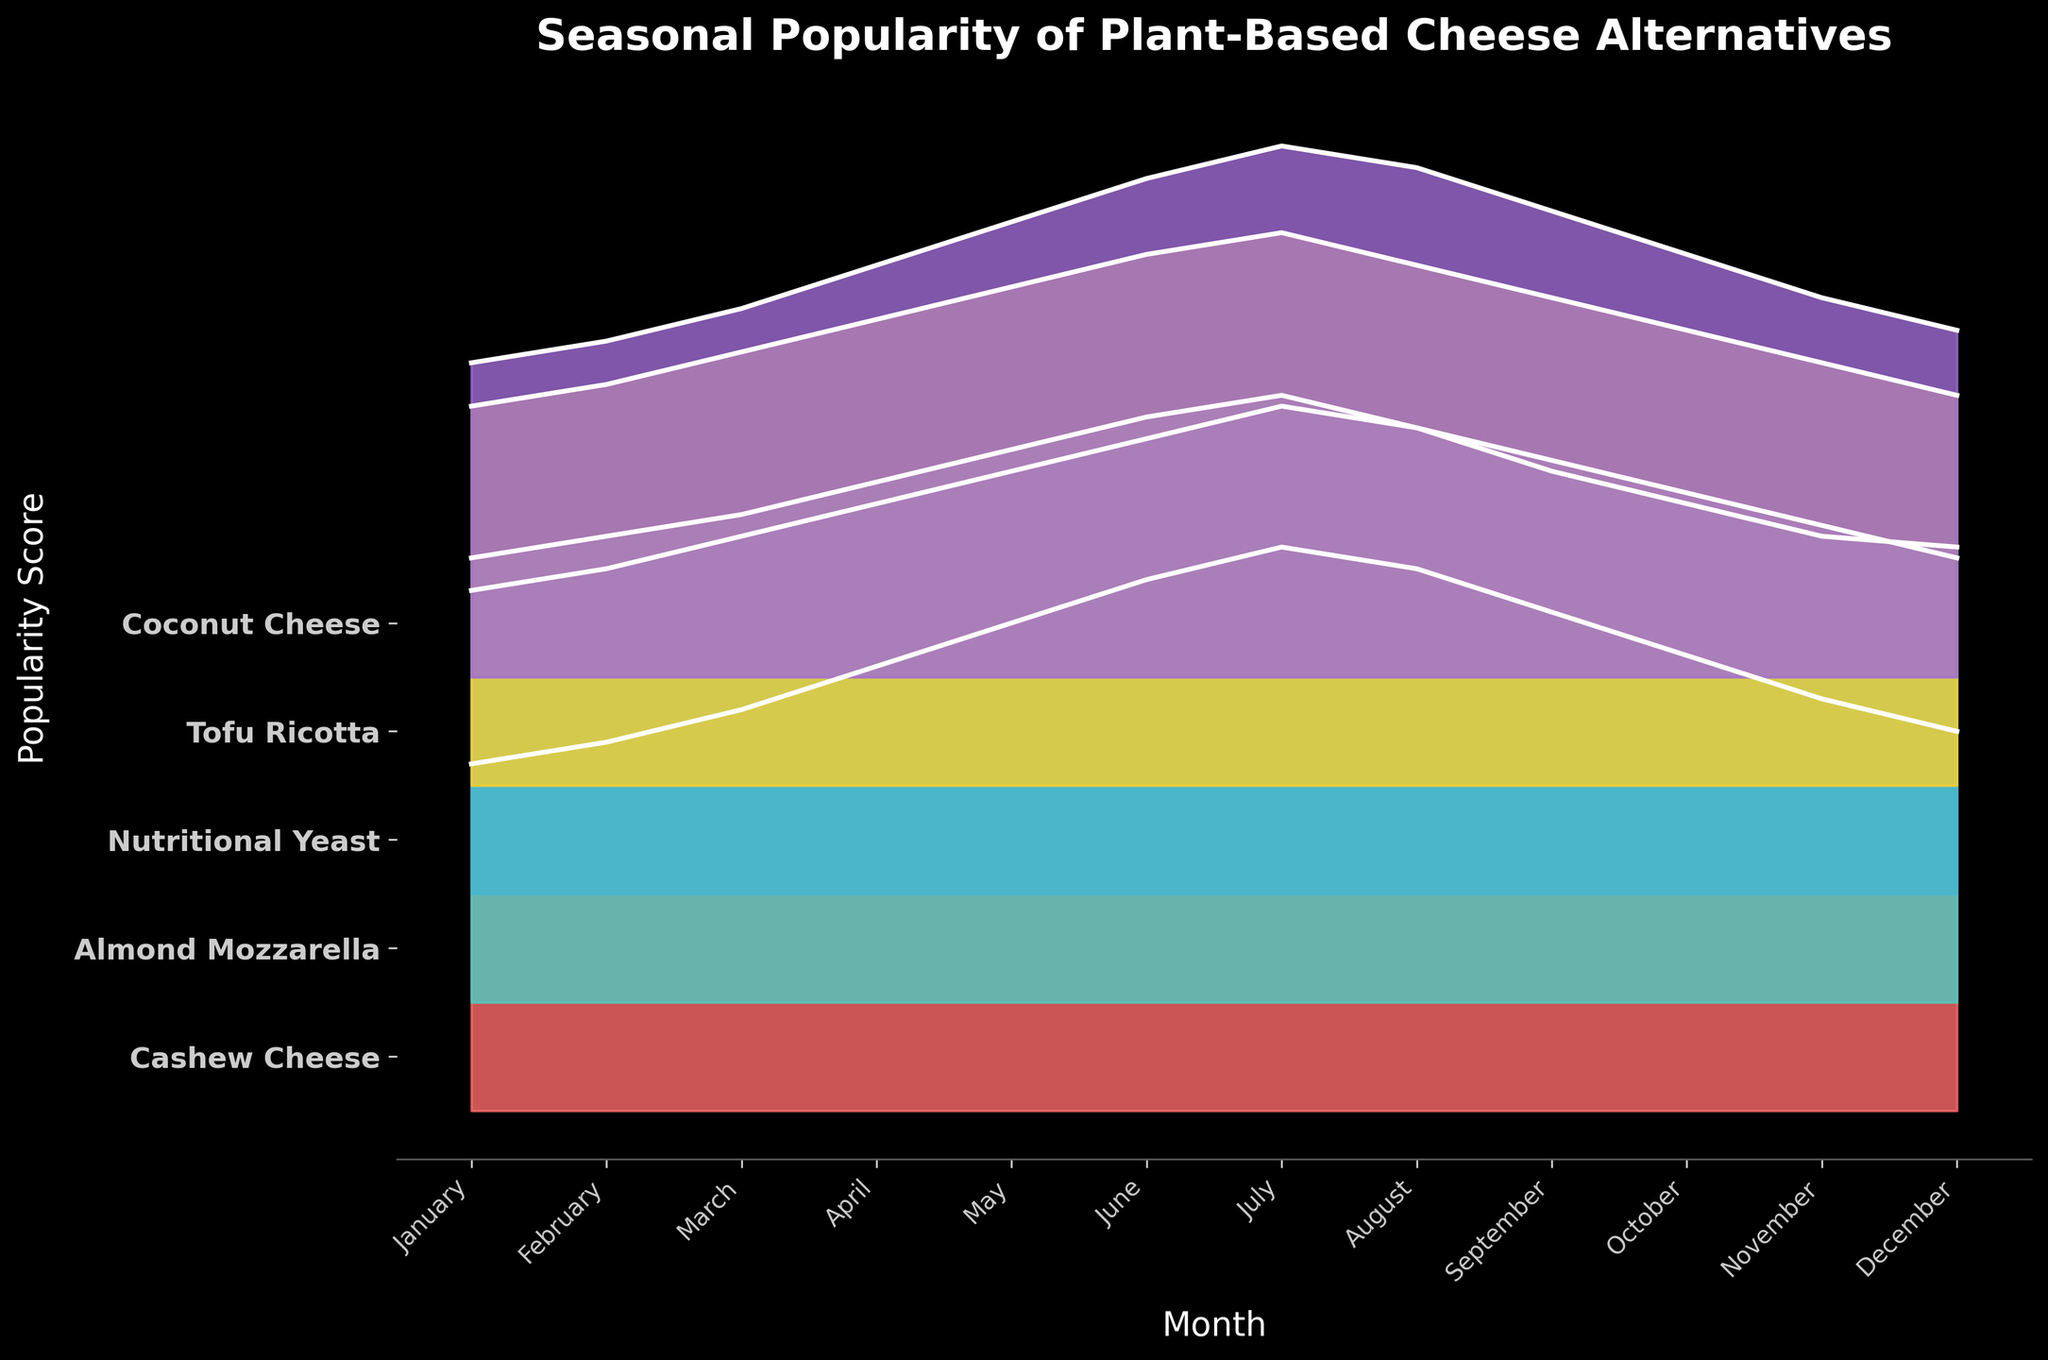What is the title of the plot? The title is at the top of the figure and reads "Seasonal Popularity of Plant-Based Cheese Alternatives".
Answer: Seasonal Popularity of Plant-Based Cheese Alternatives Which month has the highest popularity score for Cashew Cheese? By observing the plot, Cashew Cheese reaches its peak in July with a score higher than in other months.
Answer: July How many plant-based cheese alternatives are represented in the plot? The y-axis labels five different cheeses: Cashew Cheese, Almond Mozzarella, Nutritional Yeast, Tofu Ricotta, and Coconut Cheese.
Answer: Five Which cheese has the least variation in popularity throughout the year? By comparing the filled areas, Nutritional Yeast shows the least variation because its peaks and valleys are moderate compared to others.
Answer: Nutritional Yeast What is the popularity trend of Almond Mozzarella from January to December? The trend for Almond Mozzarella starts at 4.1 in January and peaks at 5.6 in July. Then it slightly decreases, finishing at 4.2 in December.
Answer: Increasing then decreasing Which two cheeses have the closest popularity scores in September? In September, the scores for Almond Mozzarella and Tofu Ricotta are closest to each other, with values of 4.9 and 4.5, respectively.
Answer: Almond Mozzarella and Tofu Ricotta What is the average popularity score of Coconut Cheese in the months with more than 4.0 ratings? The months are April (3.8), May (4.2), June (4.6), July (4.9), August (4.7), and September (4.3). Adding these values and dividing by 6 gives (3.8+4.2+4.6+4.9+4.7+4.3)/6 = 26.5/6.
Answer: 4.42 In which month do all cheeses show an upward trend in their popularity? Comparing each cheese's trend, from March to April, all cheeses show an upward trend as their scores increase during this period.
Answer: April Which cheese sees the most significant drop in popularity from its highest month to its lowest month? Cashew Cheese has the highest score in July (5.2) and drops to its lowest in January (3.2). The difference is 5.2 - 3.2 = 2.0.
Answer: Cashew Cheese Is there any month where Tofu Ricotta and Coconut Cheese have the same popularity score? There is no month where Tofu Ricotta and Coconut Cheese have the exact same popularity score, as observed from the plot's curves and y-axis ranges.
Answer: No 